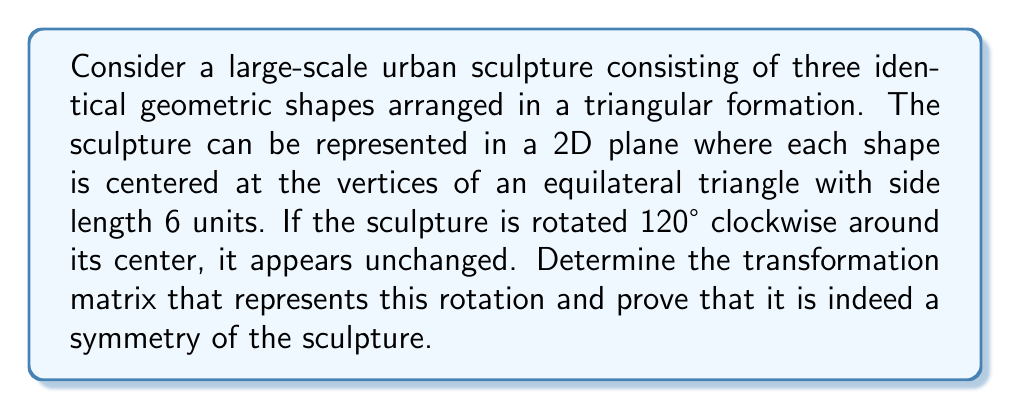Provide a solution to this math problem. To analyze the symmetry of this sculpture using transformation matrices, we'll follow these steps:

1) First, let's establish the center of rotation. For an equilateral triangle with side length 6, the center is located at $(\frac{3\sqrt{3}}{2}, \frac{3}{2})$ from the bottom-left vertex.

2) The general form of a 2D rotation matrix for a counterclockwise rotation by angle $\theta$ is:

   $$R(\theta) = \begin{pmatrix} \cos\theta & -\sin\theta \\ \sin\theta & \cos\theta \end{pmatrix}$$

3) We need a 120° clockwise rotation, which is equivalent to a -120° or 240° counterclockwise rotation. Let's use 240°. 

   $$\cos 240° = -\frac{1}{2}, \quad \sin 240° = -\frac{\sqrt{3}}{2}$$

4) Substituting these values into the rotation matrix:

   $$R(240°) = \begin{pmatrix} -\frac{1}{2} & \frac{\sqrt{3}}{2} \\ -\frac{\sqrt{3}}{2} & -\frac{1}{2} \end{pmatrix}$$

5) To apply this rotation around the center point $(x_c, y_c) = (\frac{3\sqrt{3}}{2}, \frac{3}{2})$, we need to:
   - Translate to the origin
   - Apply the rotation
   - Translate back

   This can be represented as:

   $$T = \begin{pmatrix} 1 & 0 & x_c \\ 0 & 1 & y_c \\ 0 & 0 & 1 \end{pmatrix} 
   \begin{pmatrix} -\frac{1}{2} & \frac{\sqrt{3}}{2} & 0 \\ -\frac{\sqrt{3}}{2} & -\frac{1}{2} & 0 \\ 0 & 0 & 1 \end{pmatrix}
   \begin{pmatrix} 1 & 0 & -x_c \\ 0 & 1 & -y_c \\ 0 & 0 & 1 \end{pmatrix}$$

6) Multiplying these matrices gives us the final transformation matrix:

   $$T = \begin{pmatrix} -\frac{1}{2} & \frac{\sqrt{3}}{2} & 0 \\ -\frac{\sqrt{3}}{2} & -\frac{1}{2} & 0 \\ 0 & 0 & 1 \end{pmatrix}$$

7) To prove this is a symmetry of the sculpture, we need to show that it maps each vertex of the triangle to another vertex. Let's apply T to each vertex:

   Bottom-left: $(0, 0, 1) \rightarrow (3\sqrt{3}, 0, 1)$
   Top: $(3\sqrt{3}, 3, 1) \rightarrow (0, 0, 1)$
   Bottom-right: $(3\sqrt{3}, 0, 1) \rightarrow (3\sqrt{3}, 3, 1)$

These transformations show that each vertex is mapped to another vertex, preserving the structure of the sculpture. Therefore, this transformation matrix represents a symmetry of the sculpture.
Answer: The transformation matrix representing the 120° clockwise rotation symmetry of the sculpture is:

$$T = \begin{pmatrix} -\frac{1}{2} & \frac{\sqrt{3}}{2} & 0 \\ -\frac{\sqrt{3}}{2} & -\frac{1}{2} & 0 \\ 0 & 0 & 1 \end{pmatrix}$$ 